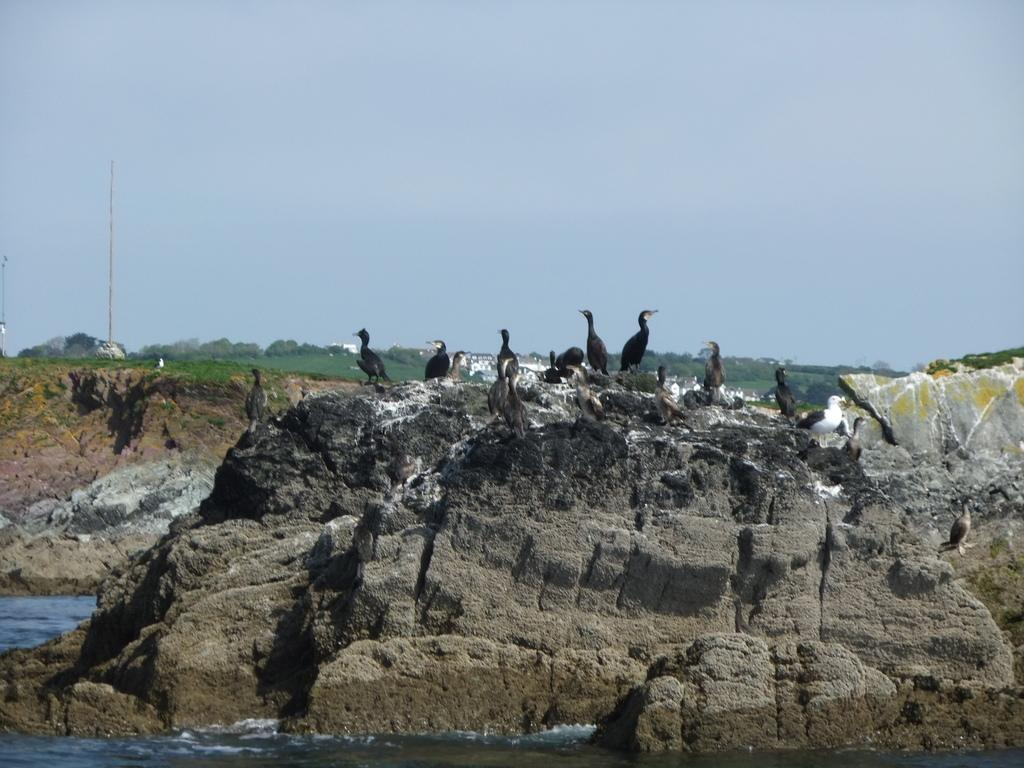What animals can be seen in the image? There are birds on rocks in the image. What natural element is present in the image? There is water visible in the image. What type of vegetation is in the image? There are trees in the image. What man-made object can be seen in the image? There is a pole in the image. What is visible in the background of the image? The sky is visible in the background of the image. What type of feather can be seen on the bed in the image? There is no bed present in the image, and therefore no feather can be seen on it. 